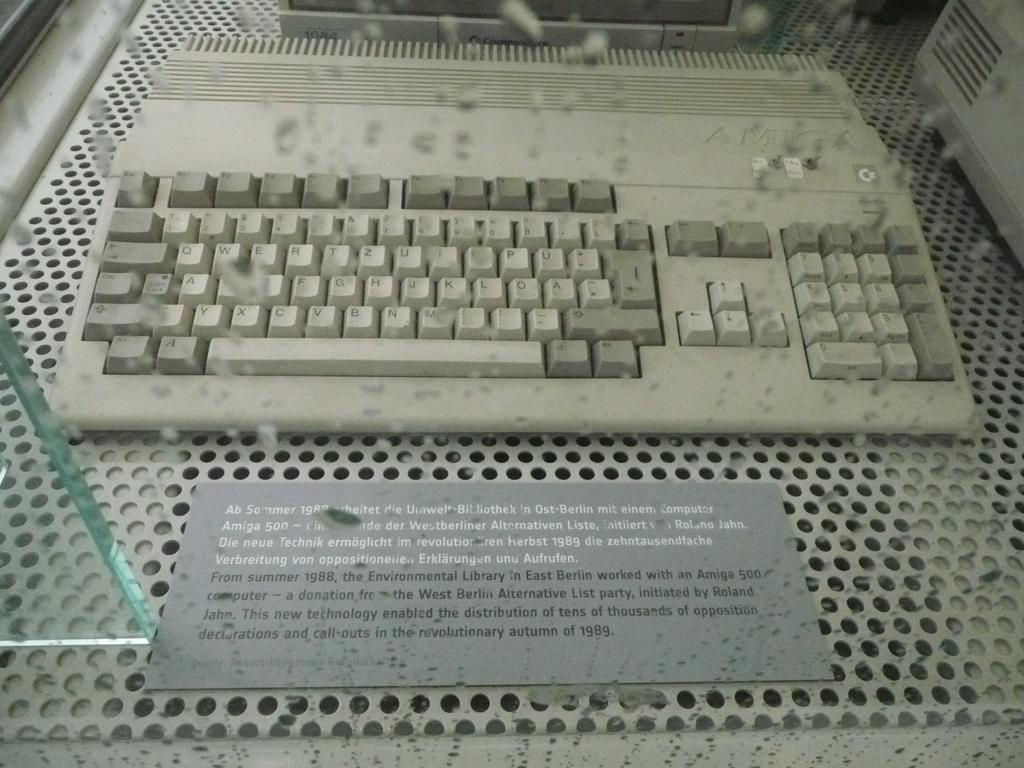<image>
Provide a brief description of the given image. a keyboard with the letter U on it 